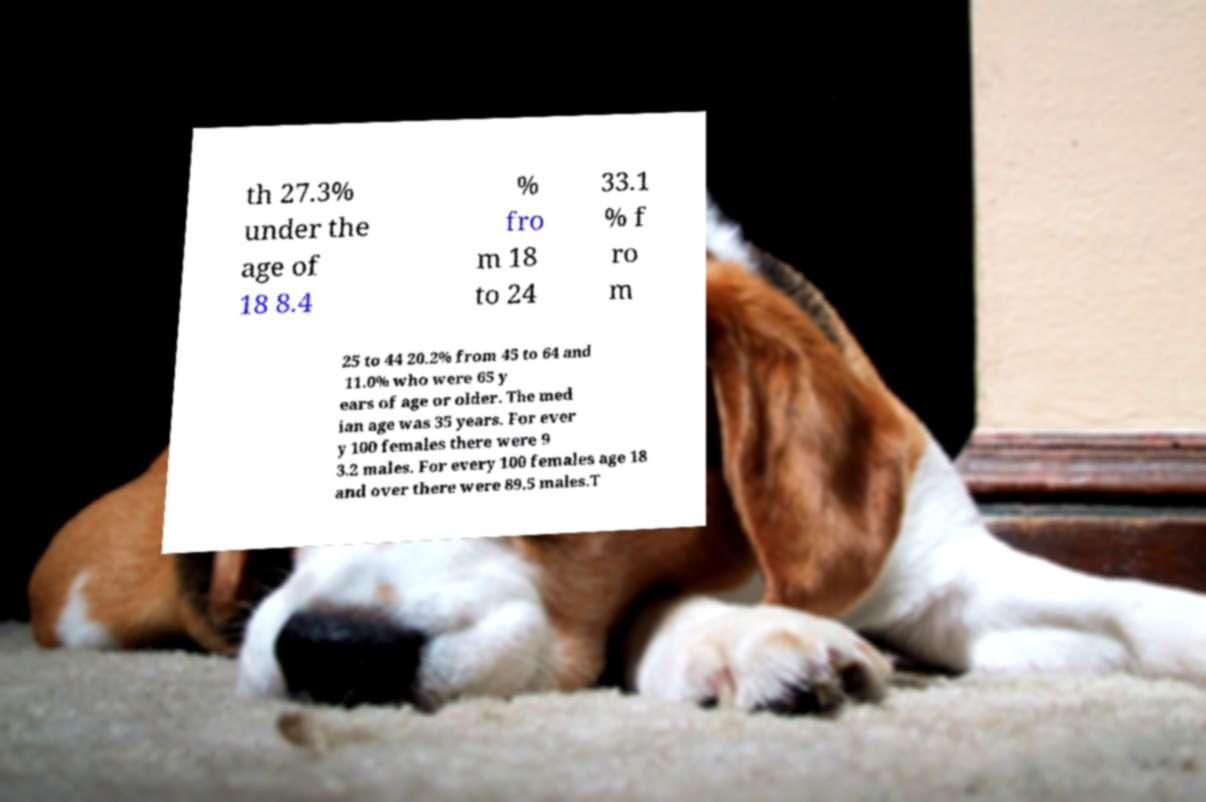Could you assist in decoding the text presented in this image and type it out clearly? th 27.3% under the age of 18 8.4 % fro m 18 to 24 33.1 % f ro m 25 to 44 20.2% from 45 to 64 and 11.0% who were 65 y ears of age or older. The med ian age was 35 years. For ever y 100 females there were 9 3.2 males. For every 100 females age 18 and over there were 89.5 males.T 